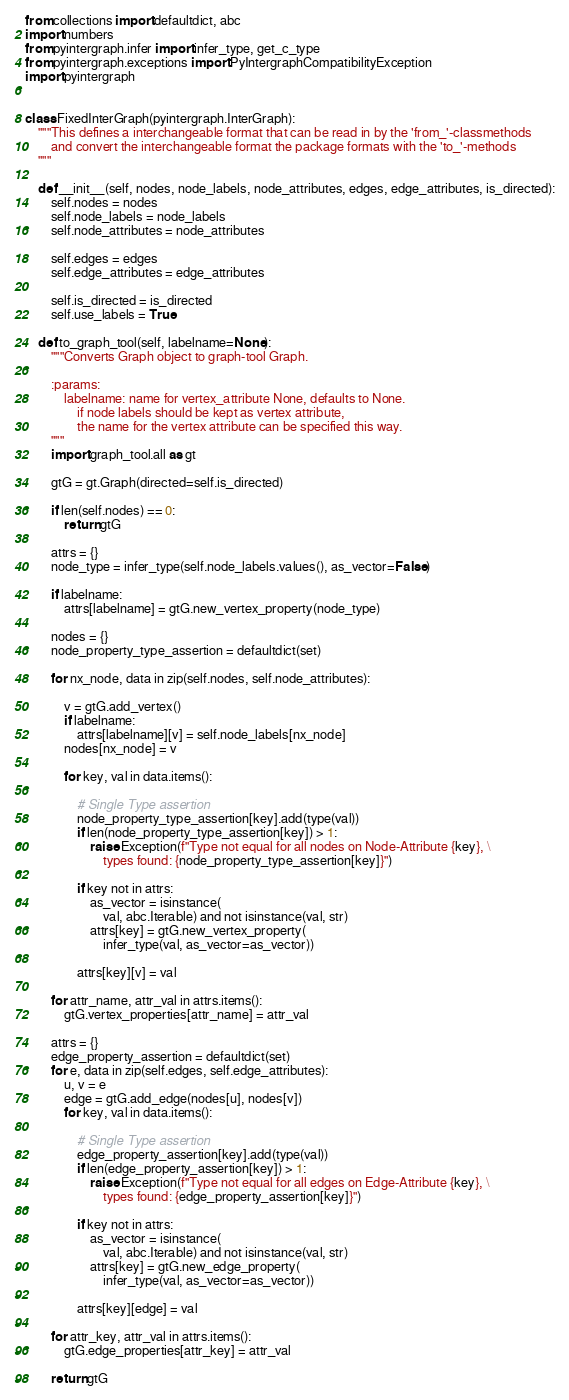<code> <loc_0><loc_0><loc_500><loc_500><_Python_>from collections import defaultdict, abc
import numbers
from pyintergraph.infer import infer_type, get_c_type
from pyintergraph.exceptions import PyIntergraphCompatibilityException
import pyintergraph


class FixedInterGraph(pyintergraph.InterGraph):
    """This defines a interchangeable format that can be read in by the 'from_'-classmethods
        and convert the interchangeable format the package formats with the 'to_'-methods
    """

    def __init__(self, nodes, node_labels, node_attributes, edges, edge_attributes, is_directed):
        self.nodes = nodes
        self.node_labels = node_labels
        self.node_attributes = node_attributes

        self.edges = edges
        self.edge_attributes = edge_attributes

        self.is_directed = is_directed
        self.use_labels = True

    def to_graph_tool(self, labelname=None):
        """Converts Graph object to graph-tool Graph.

        :params:
            labelname: name for vertex_attribute None, defaults to None.
                if node labels should be kept as vertex attribute,
                the name for the vertex attribute can be specified this way.
        """
        import graph_tool.all as gt

        gtG = gt.Graph(directed=self.is_directed)

        if len(self.nodes) == 0:
            return gtG

        attrs = {}
        node_type = infer_type(self.node_labels.values(), as_vector=False)

        if labelname:
            attrs[labelname] = gtG.new_vertex_property(node_type)

        nodes = {}
        node_property_type_assertion = defaultdict(set)

        for nx_node, data in zip(self.nodes, self.node_attributes):

            v = gtG.add_vertex()
            if labelname:
                attrs[labelname][v] = self.node_labels[nx_node]
            nodes[nx_node] = v

            for key, val in data.items():

                # Single Type assertion
                node_property_type_assertion[key].add(type(val))
                if len(node_property_type_assertion[key]) > 1:
                    raise Exception(f"Type not equal for all nodes on Node-Attribute {key}, \
                        types found: {node_property_type_assertion[key]}")

                if key not in attrs:
                    as_vector = isinstance(
                        val, abc.Iterable) and not isinstance(val, str)
                    attrs[key] = gtG.new_vertex_property(
                        infer_type(val, as_vector=as_vector))

                attrs[key][v] = val

        for attr_name, attr_val in attrs.items():
            gtG.vertex_properties[attr_name] = attr_val

        attrs = {}
        edge_property_assertion = defaultdict(set)
        for e, data in zip(self.edges, self.edge_attributes):
            u, v = e
            edge = gtG.add_edge(nodes[u], nodes[v])
            for key, val in data.items():

                # Single Type assertion
                edge_property_assertion[key].add(type(val))
                if len(edge_property_assertion[key]) > 1:
                    raise Exception(f"Type not equal for all edges on Edge-Attribute {key}, \
                        types found: {edge_property_assertion[key]}")

                if key not in attrs:
                    as_vector = isinstance(
                        val, abc.Iterable) and not isinstance(val, str)
                    attrs[key] = gtG.new_edge_property(
                        infer_type(val, as_vector=as_vector))

                attrs[key][edge] = val

        for attr_key, attr_val in attrs.items():
            gtG.edge_properties[attr_key] = attr_val

        return gtG
</code> 